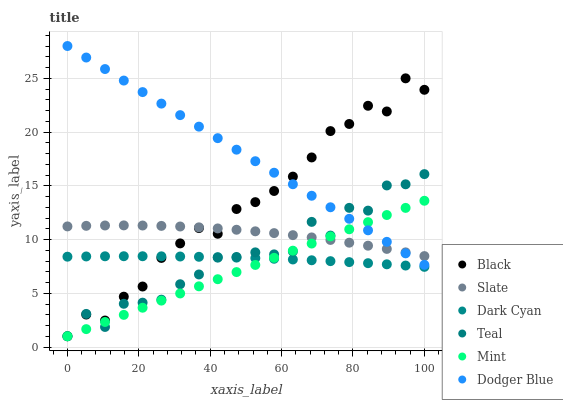Does Mint have the minimum area under the curve?
Answer yes or no. Yes. Does Dodger Blue have the maximum area under the curve?
Answer yes or no. Yes. Does Black have the minimum area under the curve?
Answer yes or no. No. Does Black have the maximum area under the curve?
Answer yes or no. No. Is Mint the smoothest?
Answer yes or no. Yes. Is Teal the roughest?
Answer yes or no. Yes. Is Black the smoothest?
Answer yes or no. No. Is Black the roughest?
Answer yes or no. No. Does Black have the lowest value?
Answer yes or no. Yes. Does Dark Cyan have the lowest value?
Answer yes or no. No. Does Dodger Blue have the highest value?
Answer yes or no. Yes. Does Black have the highest value?
Answer yes or no. No. Is Dark Cyan less than Dodger Blue?
Answer yes or no. Yes. Is Dodger Blue greater than Dark Cyan?
Answer yes or no. Yes. Does Dodger Blue intersect Black?
Answer yes or no. Yes. Is Dodger Blue less than Black?
Answer yes or no. No. Is Dodger Blue greater than Black?
Answer yes or no. No. Does Dark Cyan intersect Dodger Blue?
Answer yes or no. No. 